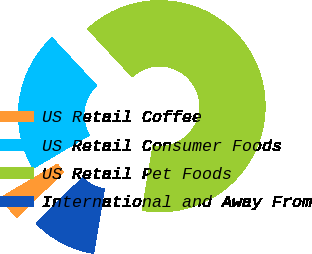Convert chart. <chart><loc_0><loc_0><loc_500><loc_500><pie_chart><fcel>US Retail Coffee<fcel>US Retail Consumer Foods<fcel>US Retail Pet Foods<fcel>International and Away From<nl><fcel>3.91%<fcel>21.53%<fcel>64.58%<fcel>9.98%<nl></chart> 